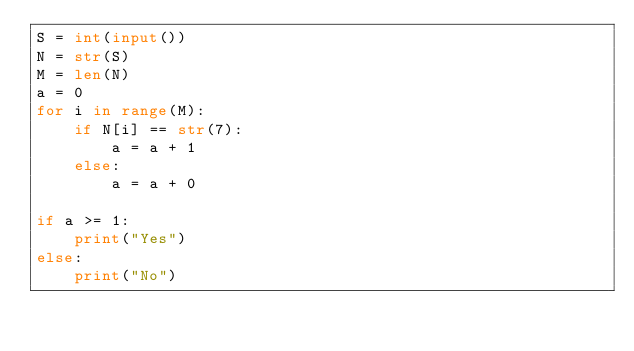<code> <loc_0><loc_0><loc_500><loc_500><_Python_>S = int(input())
N = str(S)
M = len(N)
a = 0
for i in range(M):
    if N[i] == str(7):
        a = a + 1
    else:
        a = a + 0

if a >= 1:
    print("Yes")
else:
    print("No")
</code> 